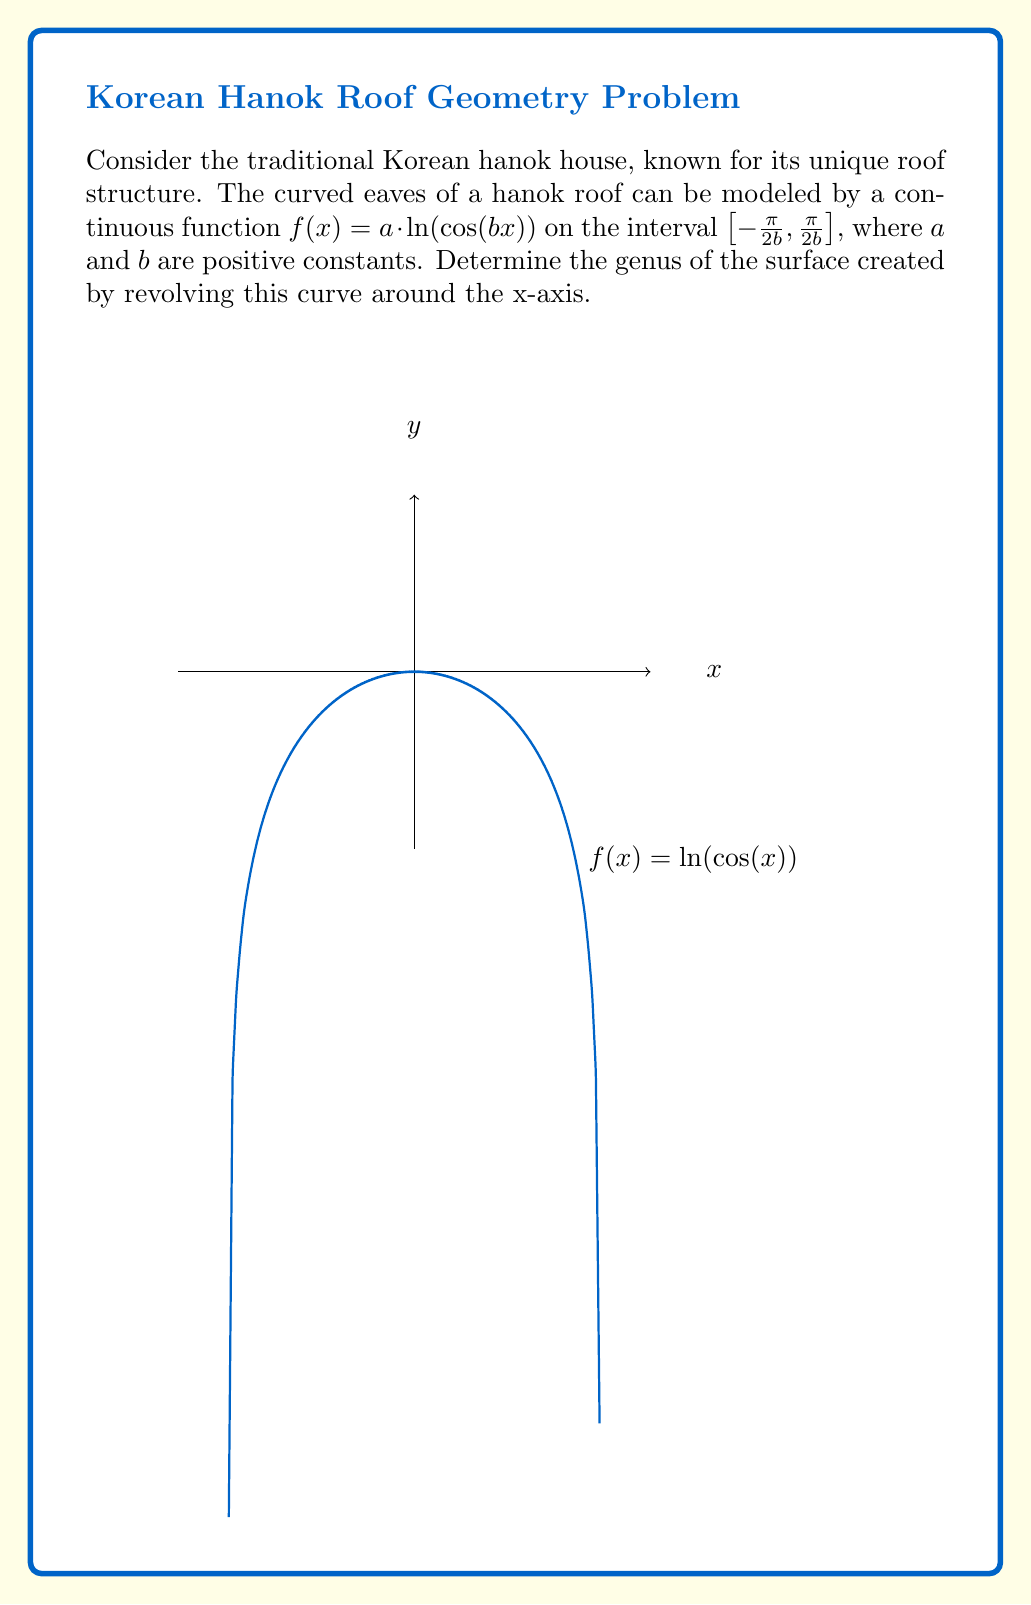Provide a solution to this math problem. To determine the genus of the surface, we need to follow these steps:

1) First, we need to check if the surface is closed. The function $f(x) = a \cdot \ln(\cos(bx))$ approaches negative infinity as $x$ approaches $\pm\frac{\pi}{2b}$. When rotated around the x-axis, this creates a surface that extends to infinity in both directions along the x-axis. Therefore, the surface is not closed.

2) For non-closed surfaces, the genus is defined as the number of "holes" in the surface. In this case, we need to count the number of times the function crosses the x-axis within its domain.

3) The function crosses the x-axis when $\ln(\cos(bx)) = 0$, which occurs when $\cos(bx) = 1$.

4) Solving $\cos(bx) = 1$:
   $bx = 2\pi n$, where $n$ is an integer
   $x = \frac{2\pi n}{b}$

5) We need to find how many of these solutions fall within the domain $[-\frac{\pi}{2b}, \frac{\pi}{2b}]$.

6) The only solution in this interval is when $n = 0$, which gives $x = 0$.

7) This means the function crosses the x-axis only once within its domain.

8) When rotated around the x-axis, this single crossing point creates a single "hole" in the surface.

Therefore, the genus of the surface is 1.
Answer: 1 